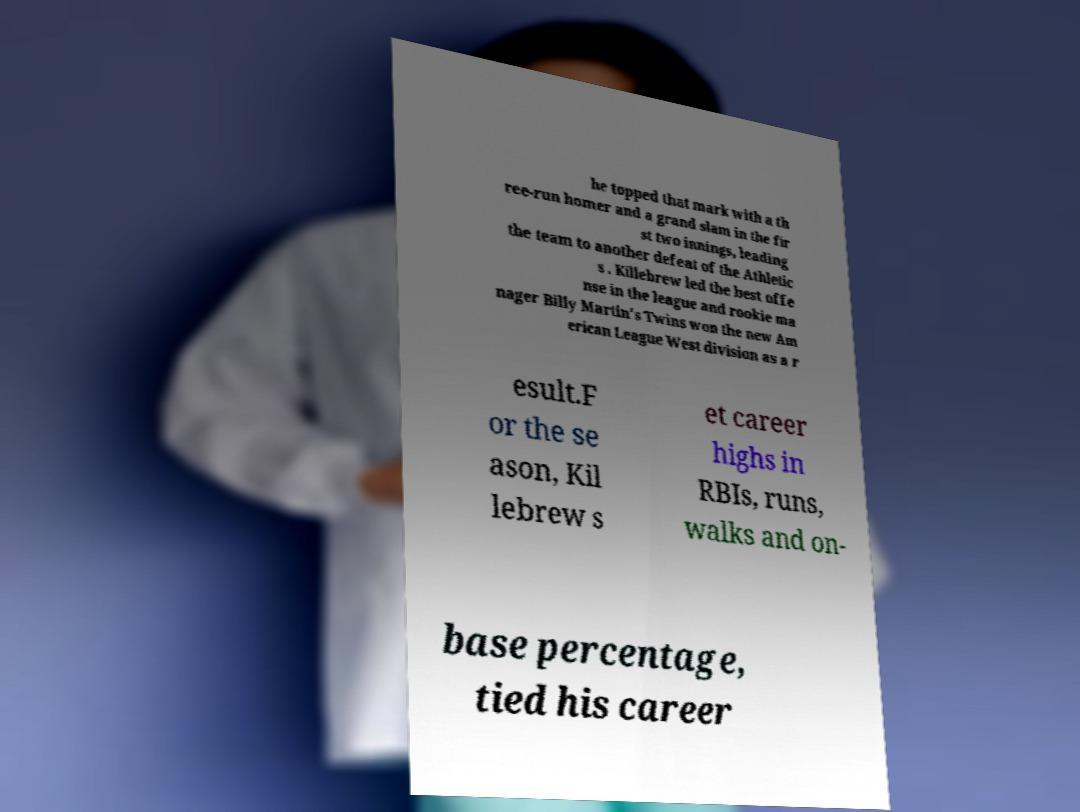Could you extract and type out the text from this image? he topped that mark with a th ree-run homer and a grand slam in the fir st two innings, leading the team to another defeat of the Athletic s . Killebrew led the best offe nse in the league and rookie ma nager Billy Martin's Twins won the new Am erican League West division as a r esult.F or the se ason, Kil lebrew s et career highs in RBIs, runs, walks and on- base percentage, tied his career 